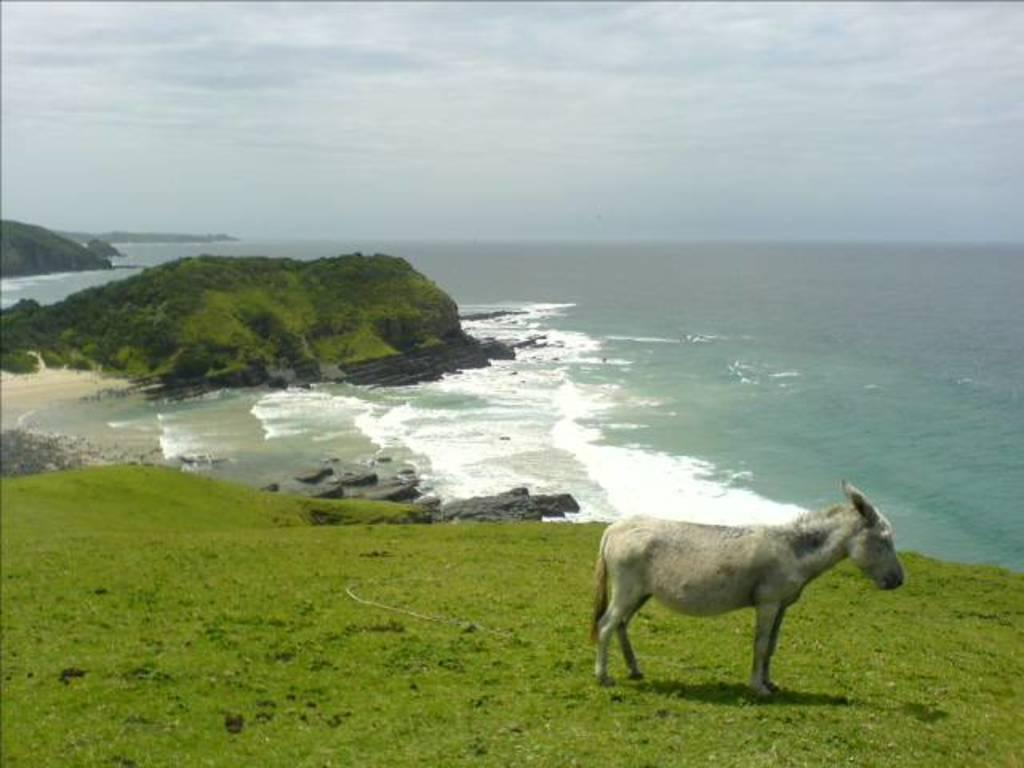What animal is in the foreground of the image? There is a donkey in the foreground of the image. What is the donkey standing on? The donkey is on grass. What type of vegetation is visible in the foreground of the image? There are trees in the foreground of the image. What can be seen in the distance in the image? There are mountains and water visible in the background of the image. What part of the natural environment is visible in the background of the image? The sky is visible in the background of the image. What might be the location of the image based on the visible features? The image may have been taken near the ocean, given the presence of mountains, water, and the sky. What type of insect can be seen crawling on the donkey's back in the image? There is no insect visible on the donkey's back in the image. What type of camping equipment can be seen in the image? There is no camping equipment present in the image. 